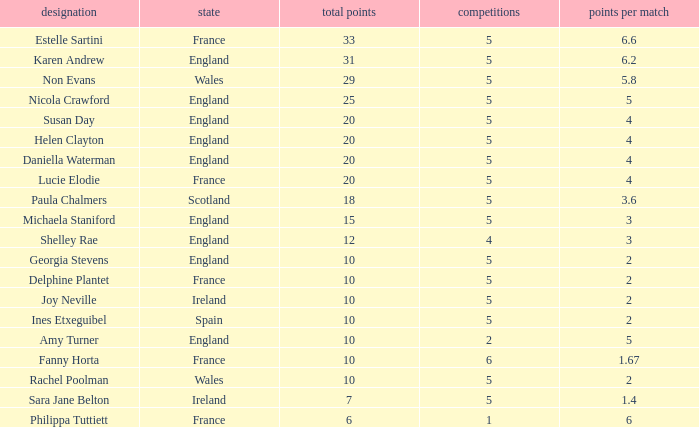Can you tell me the lowest Games that has the Pts/game larger than 1.4 and the Points of 20, and the Name of susan day? 5.0. 